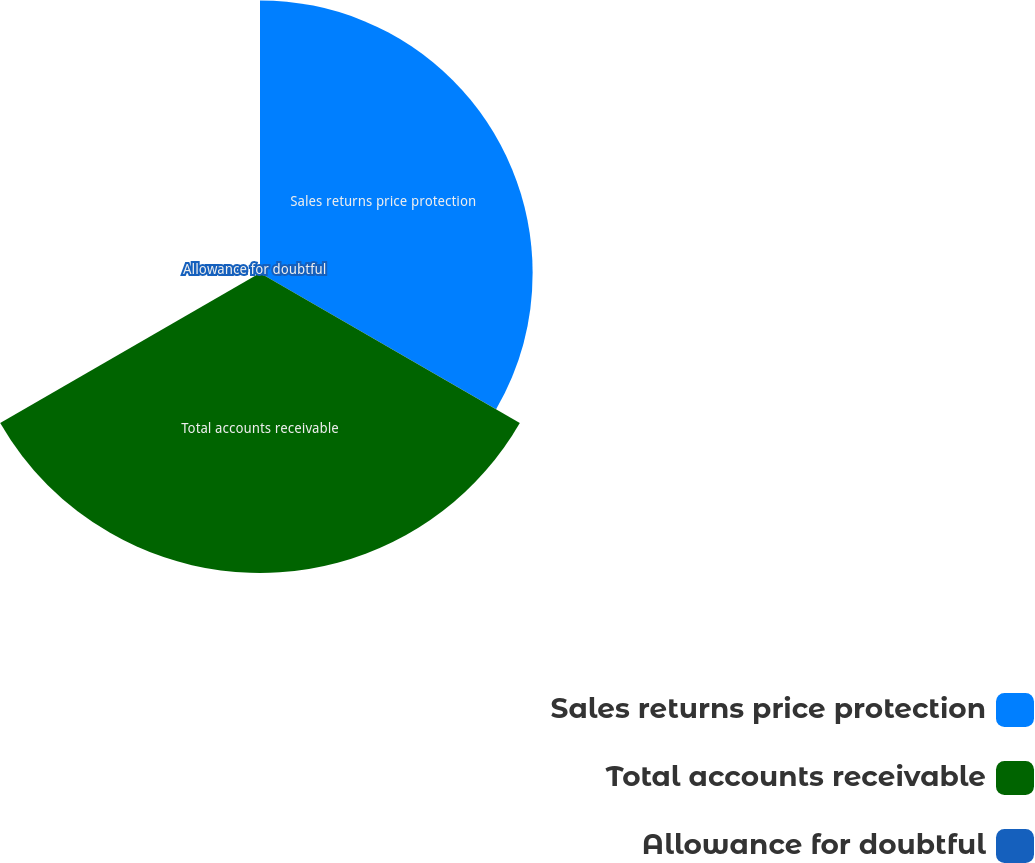<chart> <loc_0><loc_0><loc_500><loc_500><pie_chart><fcel>Sales returns price protection<fcel>Total accounts receivable<fcel>Allowance for doubtful<nl><fcel>47.6%<fcel>52.38%<fcel>0.02%<nl></chart> 